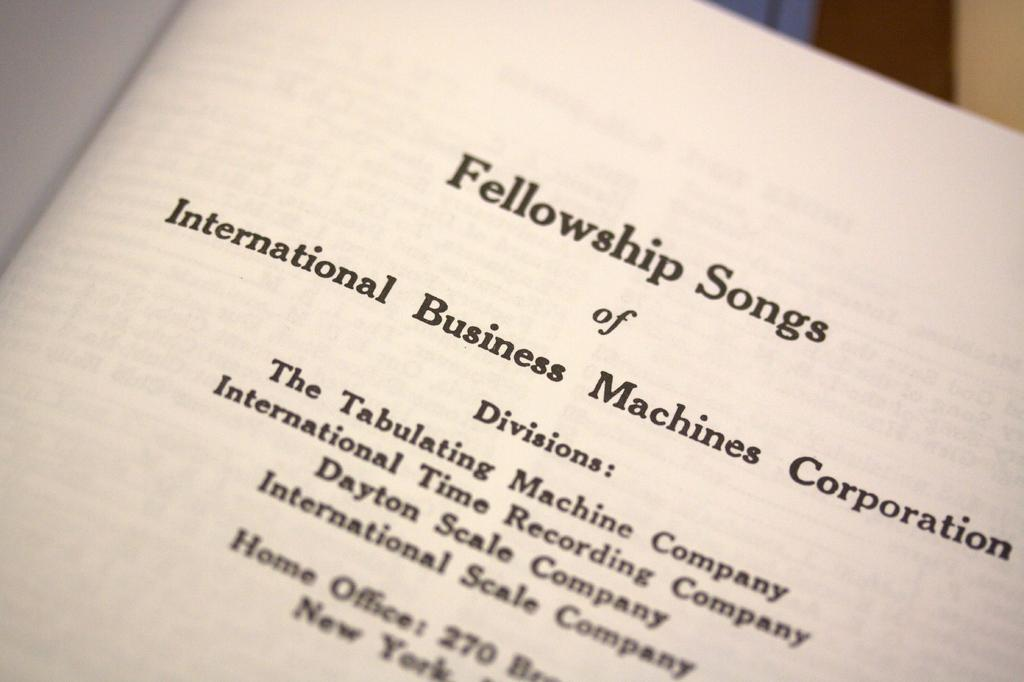What is visible on the paper in the image? There is writing on a paper in the image. Can you describe the background of the image? The background of the image is blurred. What type of stream can be seen in the image? There is no stream present in the image; it only features writing on a paper and a blurred background. 